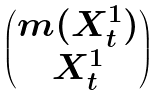<formula> <loc_0><loc_0><loc_500><loc_500>\begin{pmatrix} m ( X _ { t } ^ { 1 } ) \\ X _ { t } ^ { 1 } \end{pmatrix}</formula> 